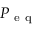<formula> <loc_0><loc_0><loc_500><loc_500>P _ { e q }</formula> 